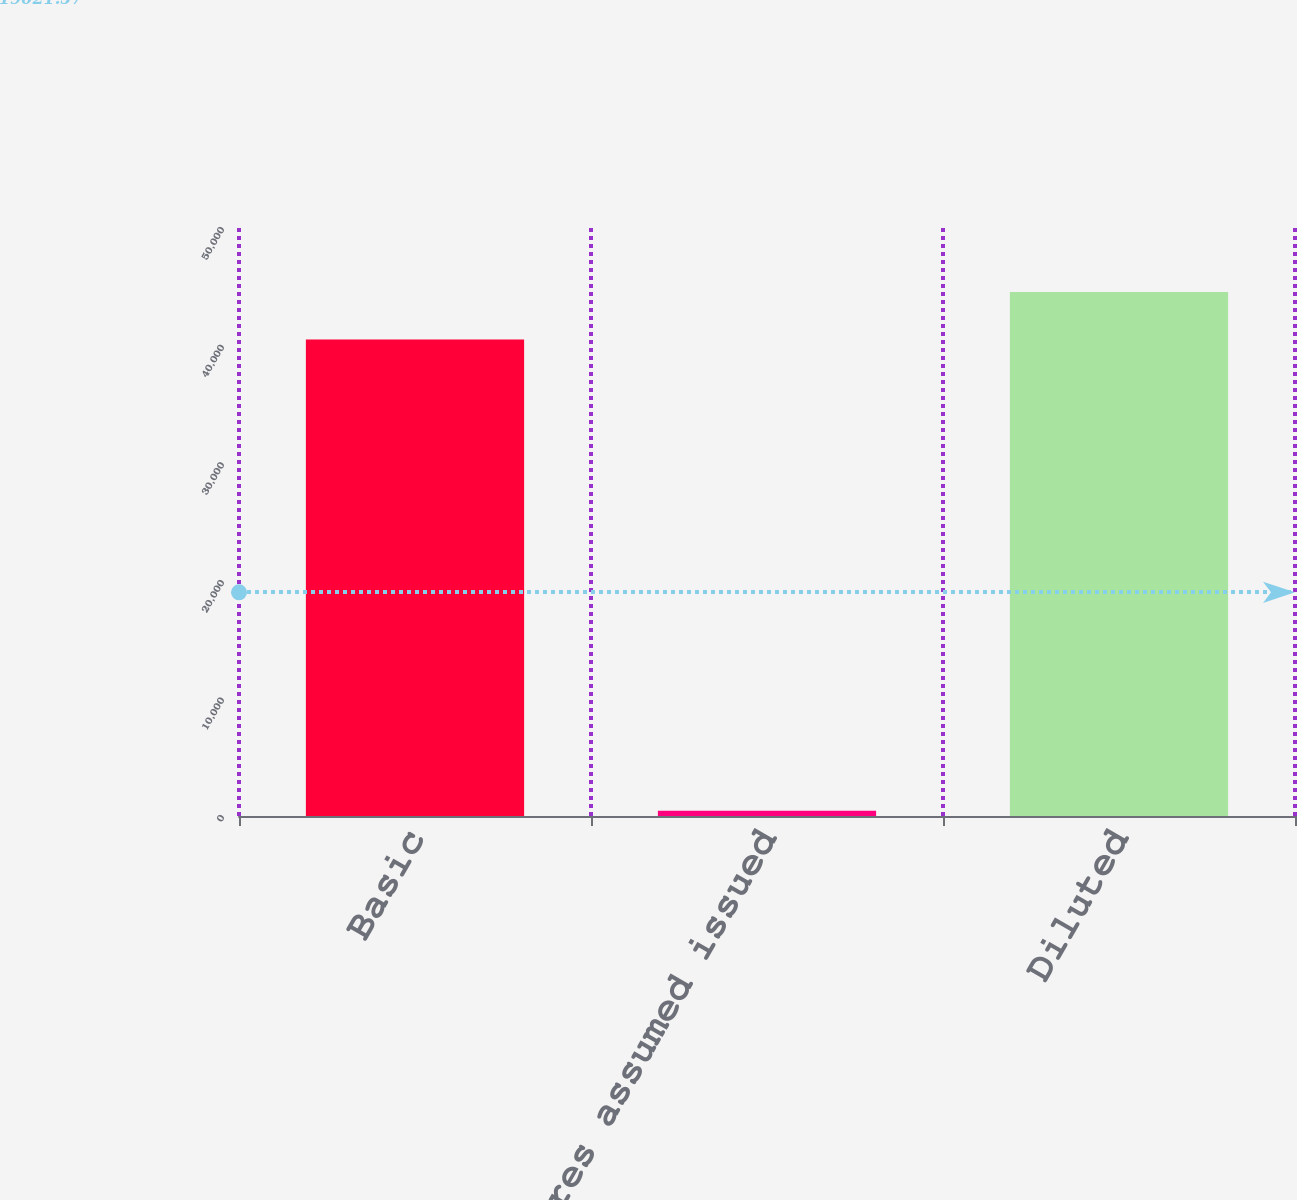Convert chart. <chart><loc_0><loc_0><loc_500><loc_500><bar_chart><fcel>Basic<fcel>Dilutive shares assumed issued<fcel>Diluted<nl><fcel>40516<fcel>442<fcel>44567.6<nl></chart> 